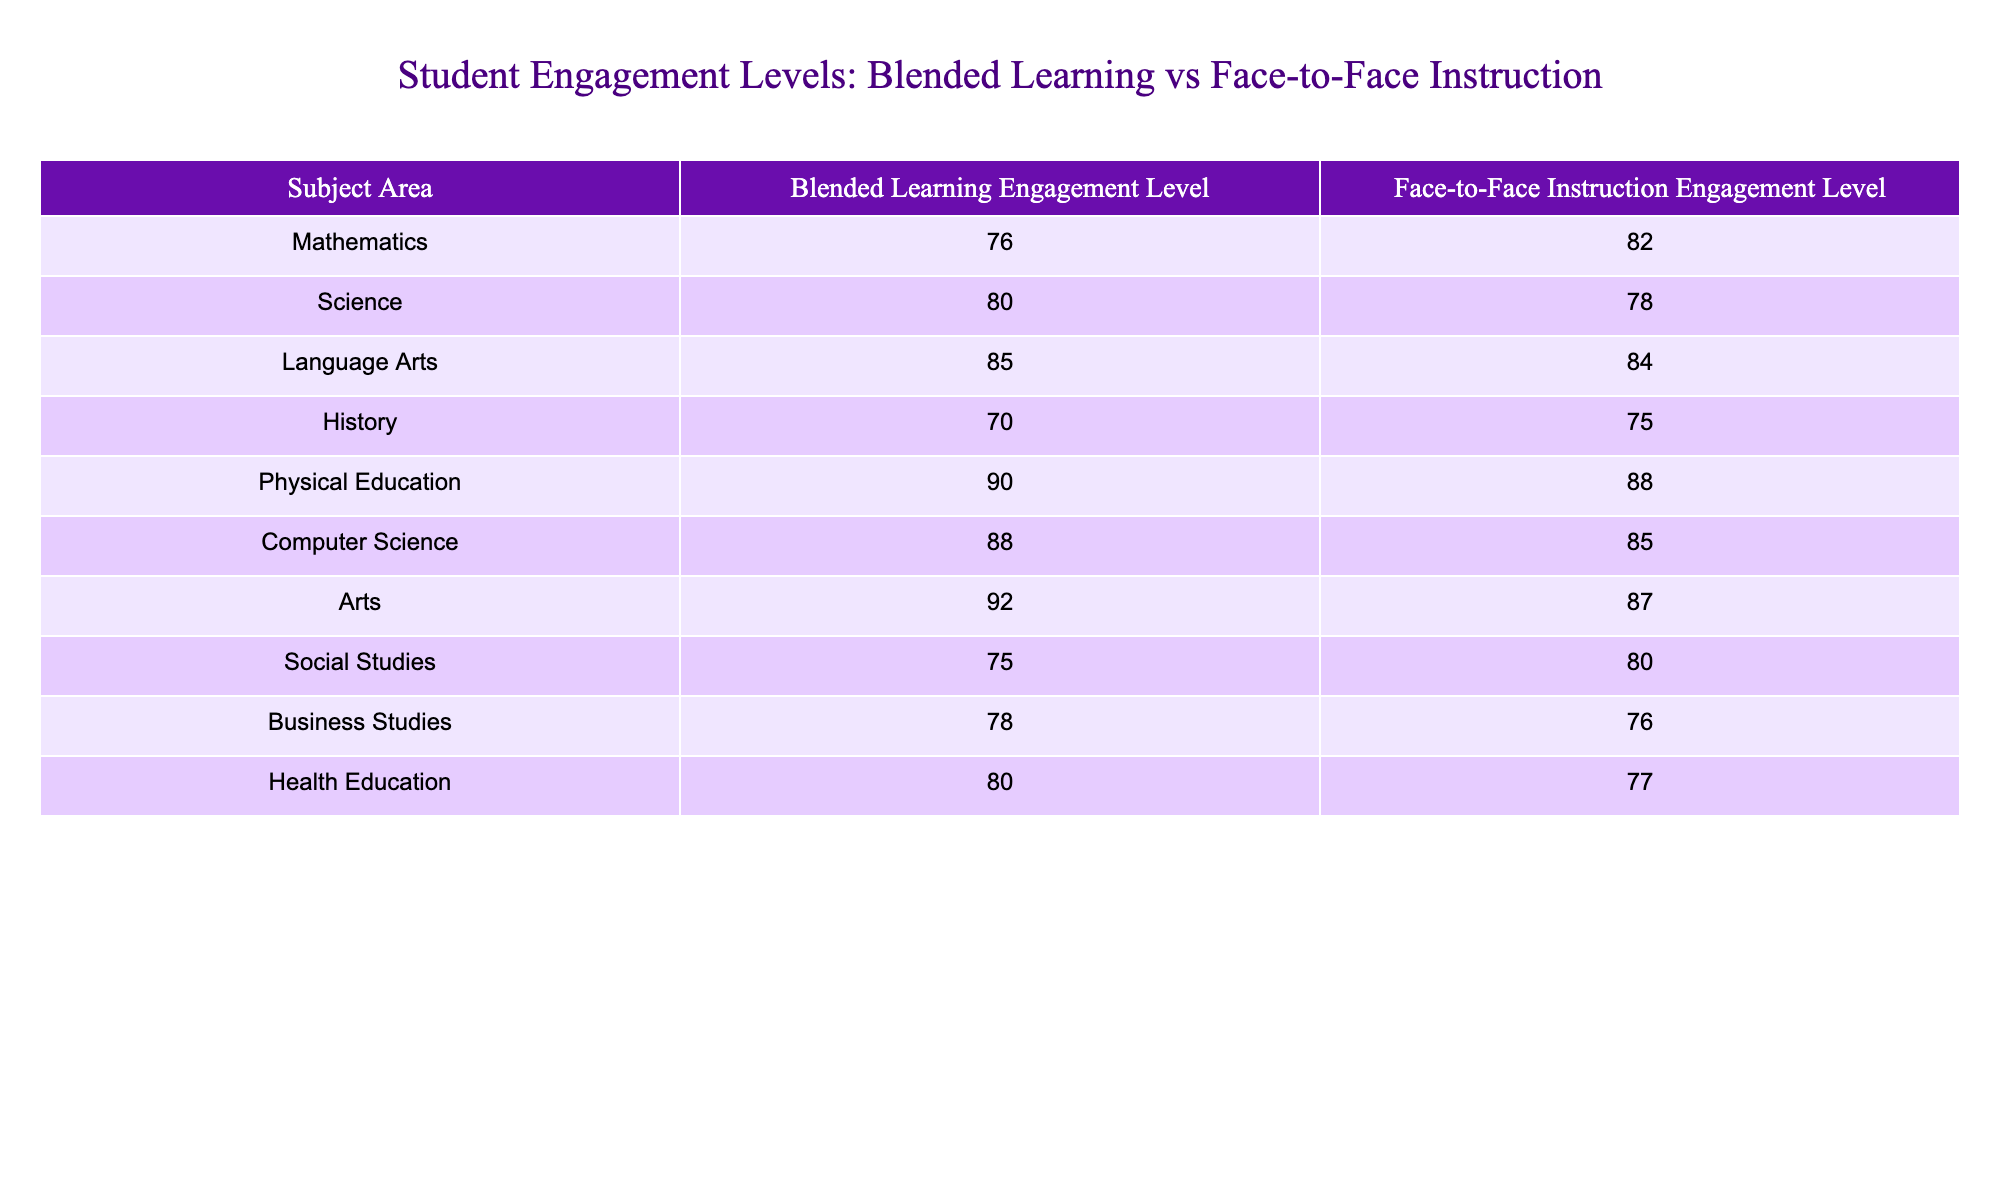What is the engagement level for Mathematics in blended learning? The table shows a specific row for Mathematics under the Blended Learning Engagement Level column. According to that row, the engagement level for Mathematics is 76.
Answer: 76 How does the engagement level in Science for blended learning compare to face-to-face instruction? In the Science row, the blended learning engagement level is 80, whereas the face-to-face instruction engagement level is 78. Comparatively, blended learning has a higher engagement level than face-to-face instruction by 2 points.
Answer: Blended learning is higher by 2 points Is the engagement level in Physical Education higher in blended learning or face-to-face instruction? Looking at the Physical Education row, the engagement level for blended learning is 90, while it is 88 for face-to-face instruction. Thus, blended learning has a higher engagement level in this subject.
Answer: Blended learning What is the average engagement level for blended learning across all subject areas? To find the average, we need to sum the blended learning engagement levels: 76 + 80 + 85 + 70 + 90 + 88 + 92 + 75 + 78 + 80 =  825. Then, divide this sum by the total number of subjects (10): 825 / 10 = 82.5.
Answer: 82.5 Is the engagement level in Social Studies lower than in Language Arts for face-to-face instruction? Checking the Social Studies row, the face-to-face engagement level is 80. In the Language Arts row, the engagement level under face-to-face instruction is 84. Since 80 is less than 84, the engagement level in Social Studies is indeed lower.
Answer: Yes What is the difference in engagement levels for Computer Science between blended learning and face-to-face instruction? The Computer Science row shows a blended learning engagement level of 88 and a face-to-face engagement level of 85. To find the difference, we subtract 85 from 88: 88 - 85 = 3. Thus, the difference is 3 points.
Answer: 3 points In which subject area is the engagement level for Blended Learning the highest? To determine the highest engagement level, we look at the Blended Learning Engagement Level column. The highest value in this column is 92 in the Arts subject area.
Answer: Arts Are there more subject areas where blended learning engagement levels are higher than face-to-face instruction levels? Checking each subject area, we can see that 6 subject areas (Science, Language Arts, Physical Education, Computer Science, Arts, Health Education) have higher engagement levels in blended learning compared to face-to-face instruction, while 4 are lower (Mathematics, History, Social Studies, Business Studies). Therefore, there are more where blended learning is higher.
Answer: Yes 